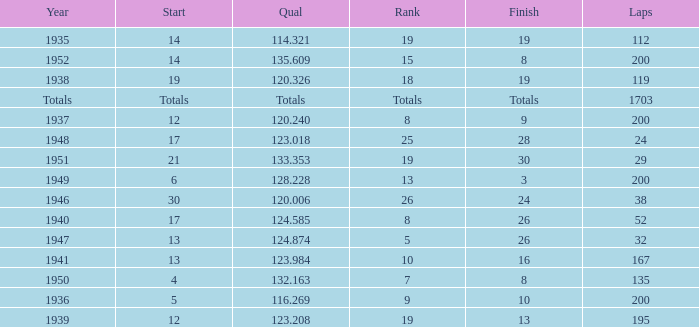In 1937, what was the finish? 9.0. 